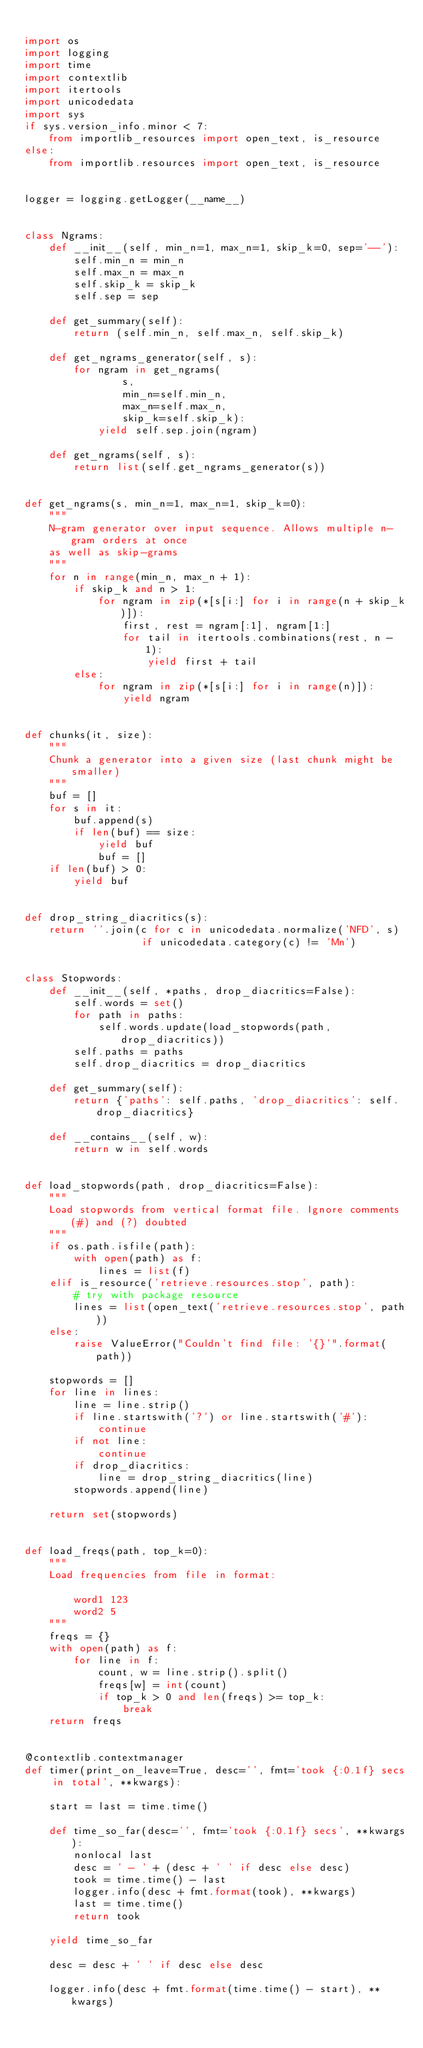<code> <loc_0><loc_0><loc_500><loc_500><_Python_>
import os
import logging
import time
import contextlib
import itertools
import unicodedata
import sys
if sys.version_info.minor < 7:
    from importlib_resources import open_text, is_resource
else:
    from importlib.resources import open_text, is_resource


logger = logging.getLogger(__name__)


class Ngrams:
    def __init__(self, min_n=1, max_n=1, skip_k=0, sep='--'):
        self.min_n = min_n
        self.max_n = max_n
        self.skip_k = skip_k
        self.sep = sep

    def get_summary(self):
        return (self.min_n, self.max_n, self.skip_k)

    def get_ngrams_generator(self, s):
        for ngram in get_ngrams(
                s,
                min_n=self.min_n,
                max_n=self.max_n,
                skip_k=self.skip_k):
            yield self.sep.join(ngram)

    def get_ngrams(self, s):
        return list(self.get_ngrams_generator(s))


def get_ngrams(s, min_n=1, max_n=1, skip_k=0):
    """
    N-gram generator over input sequence. Allows multiple n-gram orders at once
    as well as skip-grams
    """
    for n in range(min_n, max_n + 1):
        if skip_k and n > 1:
            for ngram in zip(*[s[i:] for i in range(n + skip_k)]):
                first, rest = ngram[:1], ngram[1:]
                for tail in itertools.combinations(rest, n - 1):
                    yield first + tail
        else:
            for ngram in zip(*[s[i:] for i in range(n)]):
                yield ngram


def chunks(it, size):
    """
    Chunk a generator into a given size (last chunk might be smaller)
    """
    buf = []
    for s in it:
        buf.append(s)
        if len(buf) == size:
            yield buf
            buf = []
    if len(buf) > 0:
        yield buf


def drop_string_diacritics(s):
    return ''.join(c for c in unicodedata.normalize('NFD', s)
                   if unicodedata.category(c) != 'Mn')


class Stopwords:
    def __init__(self, *paths, drop_diacritics=False):
        self.words = set()
        for path in paths:
            self.words.update(load_stopwords(path, drop_diacritics))
        self.paths = paths
        self.drop_diacritics = drop_diacritics

    def get_summary(self):
        return {'paths': self.paths, 'drop_diacritics': self.drop_diacritics}

    def __contains__(self, w):
        return w in self.words


def load_stopwords(path, drop_diacritics=False):
    """
    Load stopwords from vertical format file. Ignore comments (#) and (?) doubted
    """
    if os.path.isfile(path):
        with open(path) as f:
            lines = list(f)
    elif is_resource('retrieve.resources.stop', path):
        # try with package resource
        lines = list(open_text('retrieve.resources.stop', path))
    else:
        raise ValueError("Couldn't find file: '{}'".format(path))

    stopwords = []
    for line in lines:
        line = line.strip()
        if line.startswith('?') or line.startswith('#'):
            continue
        if not line:
            continue
        if drop_diacritics:
            line = drop_string_diacritics(line)
        stopwords.append(line)

    return set(stopwords)


def load_freqs(path, top_k=0):
    """
    Load frequencies from file in format:

        word1 123
        word2 5
    """
    freqs = {}
    with open(path) as f:
        for line in f:
            count, w = line.strip().split()
            freqs[w] = int(count)
            if top_k > 0 and len(freqs) >= top_k:
                break
    return freqs


@contextlib.contextmanager
def timer(print_on_leave=True, desc='', fmt='took {:0.1f} secs in total', **kwargs):

    start = last = time.time()

    def time_so_far(desc='', fmt='took {:0.1f} secs', **kwargs):
        nonlocal last
        desc = ' - ' + (desc + ' ' if desc else desc)
        took = time.time() - last
        logger.info(desc + fmt.format(took), **kwargs)
        last = time.time()
        return took

    yield time_so_far

    desc = desc + ' ' if desc else desc

    logger.info(desc + fmt.format(time.time() - start), **kwargs)
</code> 